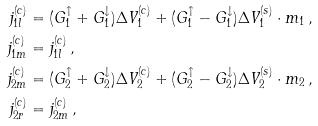<formula> <loc_0><loc_0><loc_500><loc_500>j _ { 1 l } ^ { ( c ) } & = ( G _ { 1 } ^ { \uparrow } + G _ { 1 } ^ { \downarrow } ) \Delta V _ { 1 } ^ { ( c ) } + ( G _ { 1 } ^ { \uparrow } - G _ { 1 } ^ { \downarrow } ) \Delta { V } _ { 1 } ^ { ( s ) } \cdot { m } _ { 1 } \, , \\ j _ { 1 m } ^ { ( c ) } & = j _ { 1 l } ^ { ( c ) } \, , \\ j _ { 2 m } ^ { ( c ) } & = ( G _ { 2 } ^ { \uparrow } + G _ { 2 } ^ { \downarrow } ) \Delta V _ { 2 } ^ { ( c ) } + ( G _ { 2 } ^ { \uparrow } - G _ { 2 } ^ { \downarrow } ) \Delta { V } _ { 2 } ^ { ( s ) } \cdot { m } _ { 2 } \, , \\ j _ { 2 r } ^ { ( c ) } & = j _ { 2 m } ^ { ( c ) } \, ,</formula> 